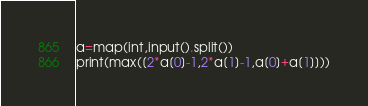<code> <loc_0><loc_0><loc_500><loc_500><_Python_>a=map(int,input().split())
print(max([2*a[0]-1,2*a[1]-1,a[0]+a[1]]))</code> 